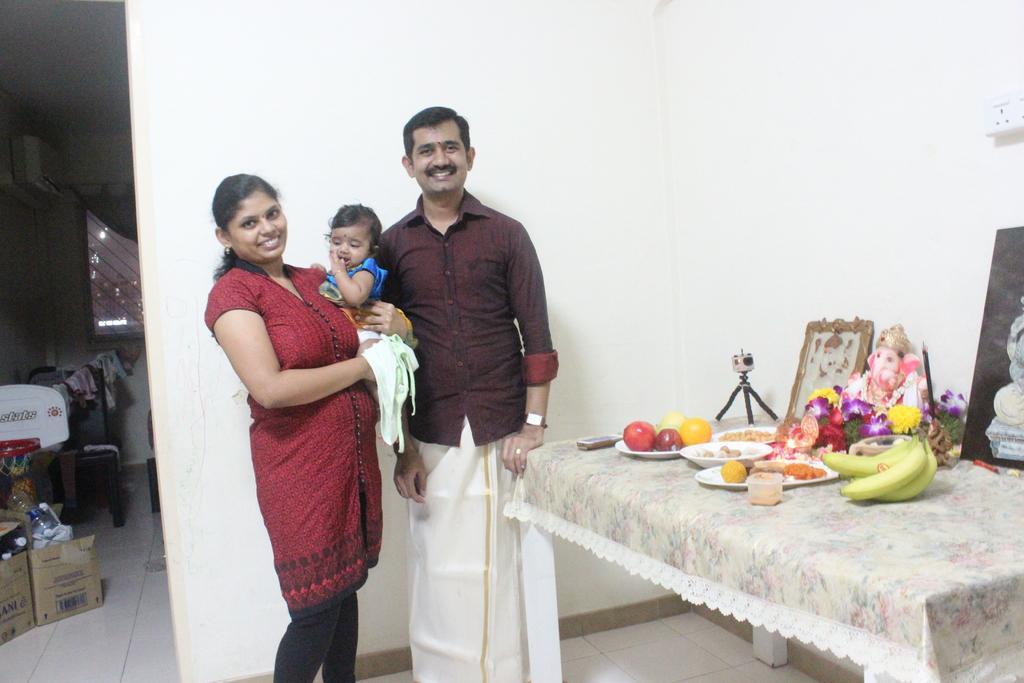Please provide a concise description of this image. In this image I can see three people. In front of them there is a statue of Ganesh. In front of Ganesha there are some eating material. At the back of these people there are some objects and the card board box. 